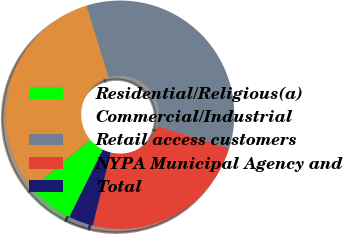<chart> <loc_0><loc_0><loc_500><loc_500><pie_chart><fcel>Residential/Religious(a)<fcel>Commercial/Industrial<fcel>Retail access customers<fcel>NYPA Municipal Agency and<fcel>Total<nl><fcel>6.59%<fcel>31.35%<fcel>34.52%<fcel>24.07%<fcel>3.48%<nl></chart> 